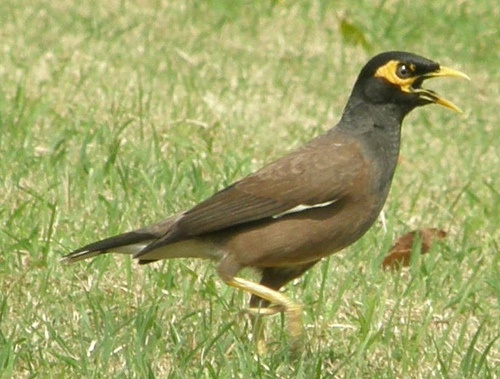Describe the objects in this image and their specific colors. I can see a bird in khaki, olive, gray, and tan tones in this image. 